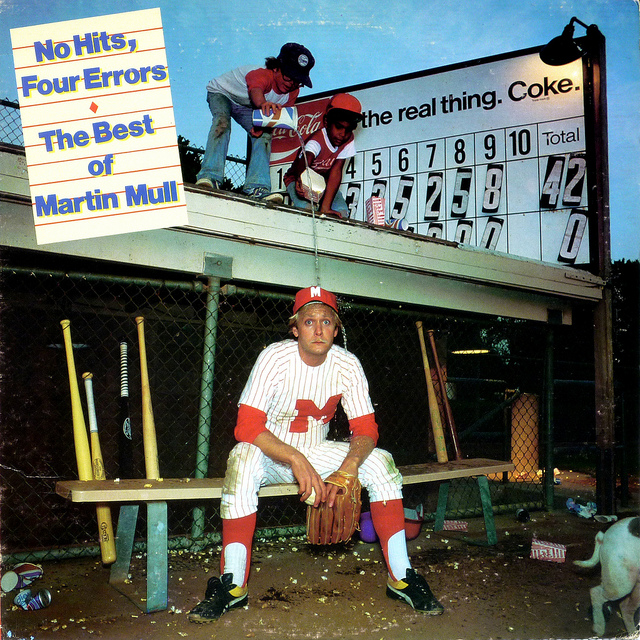<image>What is the guy about to catch? I am not sure what the guy is about to catch. It can be a ball, baseball, drink, or water. What is the guy about to catch? I am not sure what the guy is about to catch. It can be seen a ball or a baseball. 